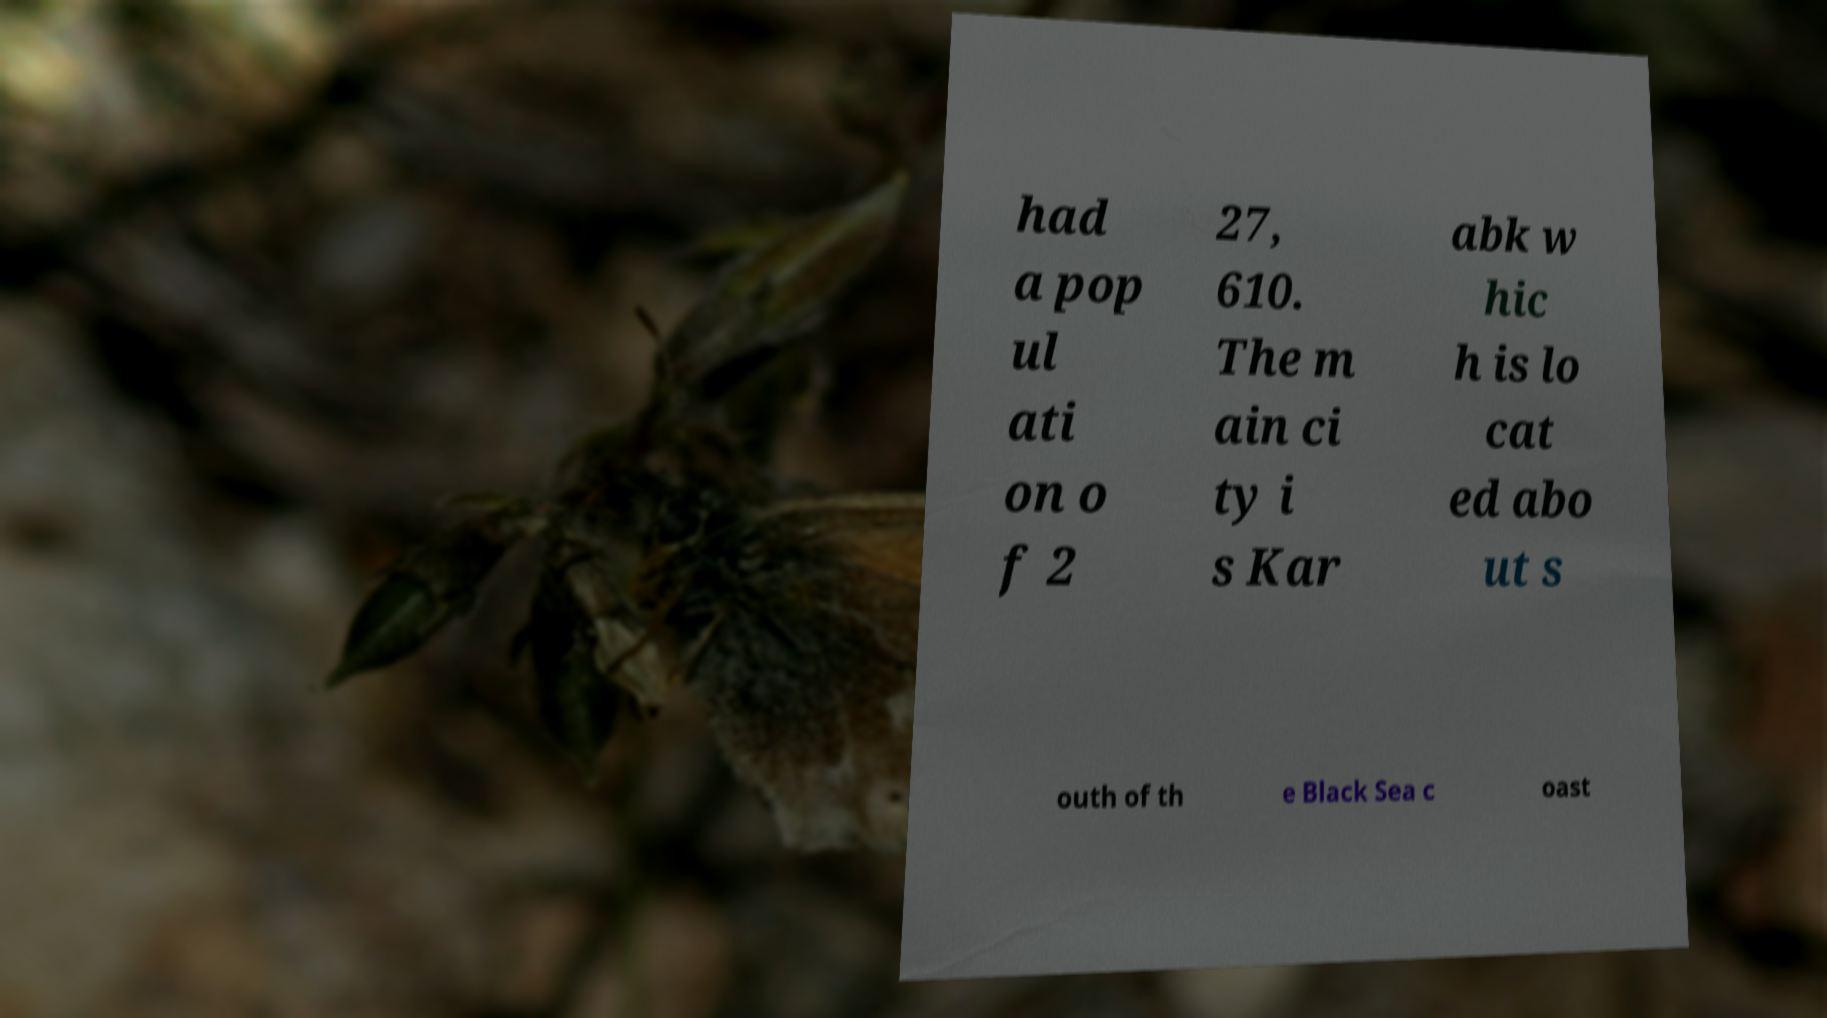There's text embedded in this image that I need extracted. Can you transcribe it verbatim? had a pop ul ati on o f 2 27, 610. The m ain ci ty i s Kar abk w hic h is lo cat ed abo ut s outh of th e Black Sea c oast 